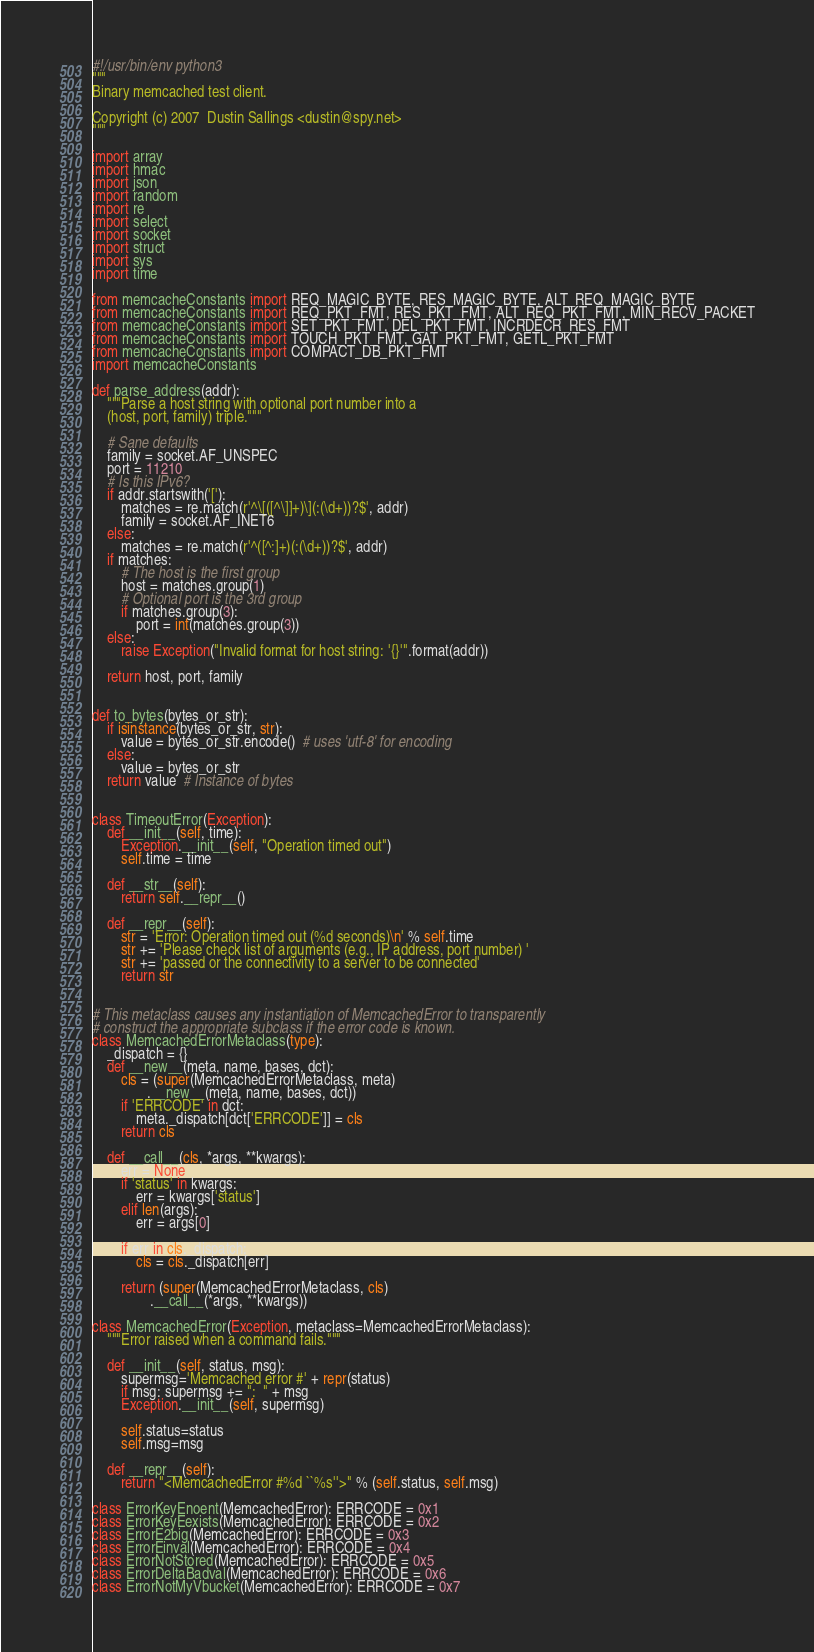<code> <loc_0><loc_0><loc_500><loc_500><_Python_>#!/usr/bin/env python3
"""
Binary memcached test client.

Copyright (c) 2007  Dustin Sallings <dustin@spy.net>
"""

import array
import hmac
import json
import random
import re
import select
import socket
import struct
import sys
import time

from memcacheConstants import REQ_MAGIC_BYTE, RES_MAGIC_BYTE, ALT_REQ_MAGIC_BYTE
from memcacheConstants import REQ_PKT_FMT, RES_PKT_FMT, ALT_REQ_PKT_FMT, MIN_RECV_PACKET
from memcacheConstants import SET_PKT_FMT, DEL_PKT_FMT, INCRDECR_RES_FMT
from memcacheConstants import TOUCH_PKT_FMT, GAT_PKT_FMT, GETL_PKT_FMT
from memcacheConstants import COMPACT_DB_PKT_FMT
import memcacheConstants

def parse_address(addr):
    """Parse a host string with optional port number into a
    (host, port, family) triple."""

    # Sane defaults
    family = socket.AF_UNSPEC
    port = 11210
    # Is this IPv6?
    if addr.startswith('['):
        matches = re.match(r'^\[([^\]]+)\](:(\d+))?$', addr)
        family = socket.AF_INET6
    else:
        matches = re.match(r'^([^:]+)(:(\d+))?$', addr)
    if matches:
        # The host is the first group
        host = matches.group(1)
        # Optional port is the 3rd group
        if matches.group(3):
            port = int(matches.group(3))
    else:
        raise Exception("Invalid format for host string: '{}'".format(addr))

    return host, port, family


def to_bytes(bytes_or_str):
    if isinstance(bytes_or_str, str):
        value = bytes_or_str.encode()  # uses 'utf-8' for encoding
    else:
        value = bytes_or_str
    return value  # Instance of bytes


class TimeoutError(Exception):
    def __init__(self, time):
        Exception.__init__(self, "Operation timed out")
        self.time = time

    def __str__(self):
        return self.__repr__()

    def __repr__(self):
        str = 'Error: Operation timed out (%d seconds)\n' % self.time
        str += 'Please check list of arguments (e.g., IP address, port number) '
        str += 'passed or the connectivity to a server to be connected'
        return str


# This metaclass causes any instantiation of MemcachedError to transparently
# construct the appropriate subclass if the error code is known.
class MemcachedErrorMetaclass(type):
    _dispatch = {}
    def __new__(meta, name, bases, dct):
        cls = (super(MemcachedErrorMetaclass, meta)
               .__new__(meta, name, bases, dct))
        if 'ERRCODE' in dct:
            meta._dispatch[dct['ERRCODE']] = cls
        return cls

    def __call__(cls, *args, **kwargs):
        err = None
        if 'status' in kwargs:
            err = kwargs['status']
        elif len(args):
            err = args[0]

        if err in cls._dispatch:
            cls = cls._dispatch[err]

        return (super(MemcachedErrorMetaclass, cls)
                .__call__(*args, **kwargs))

class MemcachedError(Exception, metaclass=MemcachedErrorMetaclass):
    """Error raised when a command fails."""

    def __init__(self, status, msg):
        supermsg='Memcached error #' + repr(status)
        if msg: supermsg += ":  " + msg
        Exception.__init__(self, supermsg)

        self.status=status
        self.msg=msg

    def __repr__(self):
        return "<MemcachedError #%d ``%s''>" % (self.status, self.msg)

class ErrorKeyEnoent(MemcachedError): ERRCODE = 0x1
class ErrorKeyEexists(MemcachedError): ERRCODE = 0x2
class ErrorE2big(MemcachedError): ERRCODE = 0x3
class ErrorEinval(MemcachedError): ERRCODE = 0x4
class ErrorNotStored(MemcachedError): ERRCODE = 0x5
class ErrorDeltaBadval(MemcachedError): ERRCODE = 0x6
class ErrorNotMyVbucket(MemcachedError): ERRCODE = 0x7</code> 